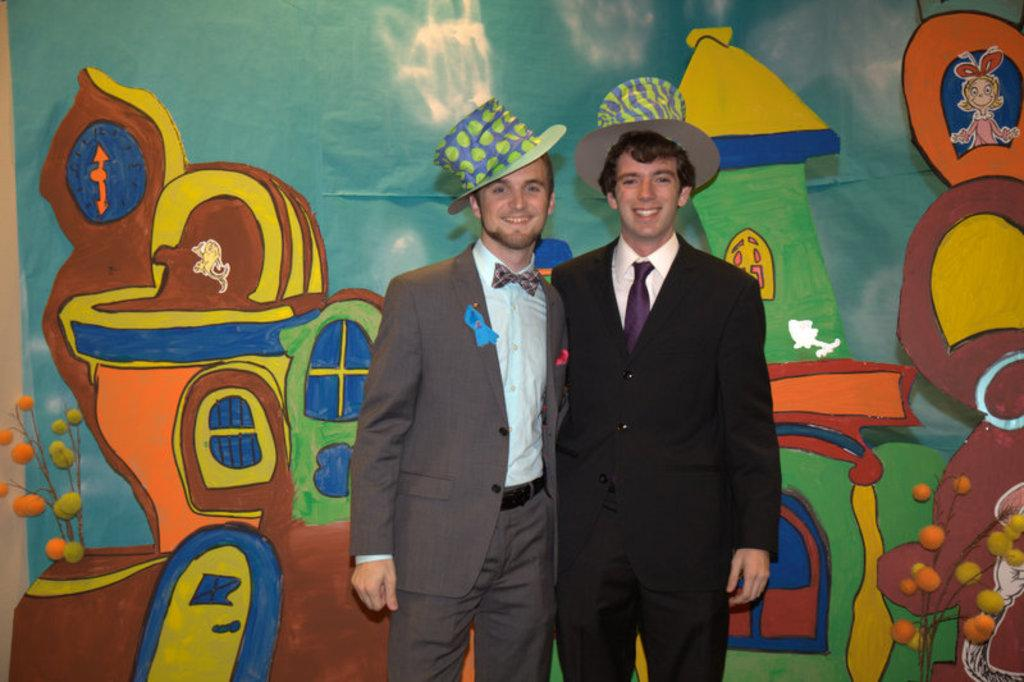How many people are present in the image? There are two people standing in the image. Can you describe the painting on the wall in the image? Unfortunately, the provided facts do not give any details about the painting on the wall. What might be the purpose of the people standing in the image? The purpose of the people standing in the image cannot be determined from the provided facts. Can you tell me how many hours the crown has been on the person's head in the image? There is no crown present in the image, so it is not possible to determine how many hours it has been on the person's head. 